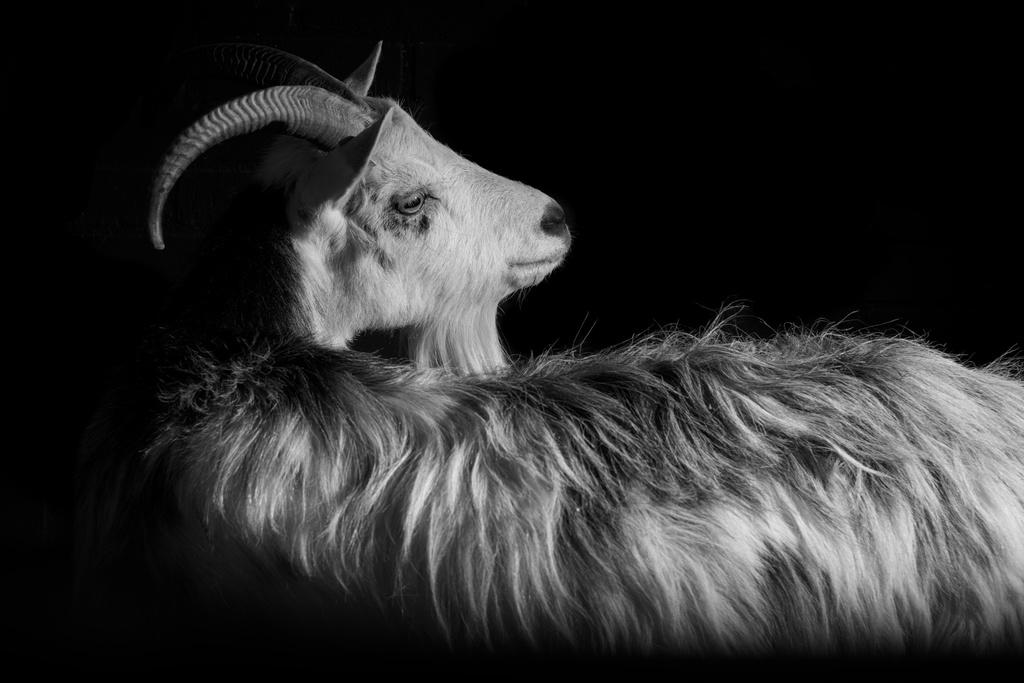What type of animal is in the picture? There is a white-colored goat in the picture. What can be observed about the background of the picture? The background of the picture is dark. What religious ceremony is taking place in the picture? There is no indication of a religious ceremony in the picture; it simply features a white-colored goat in a dark background. 